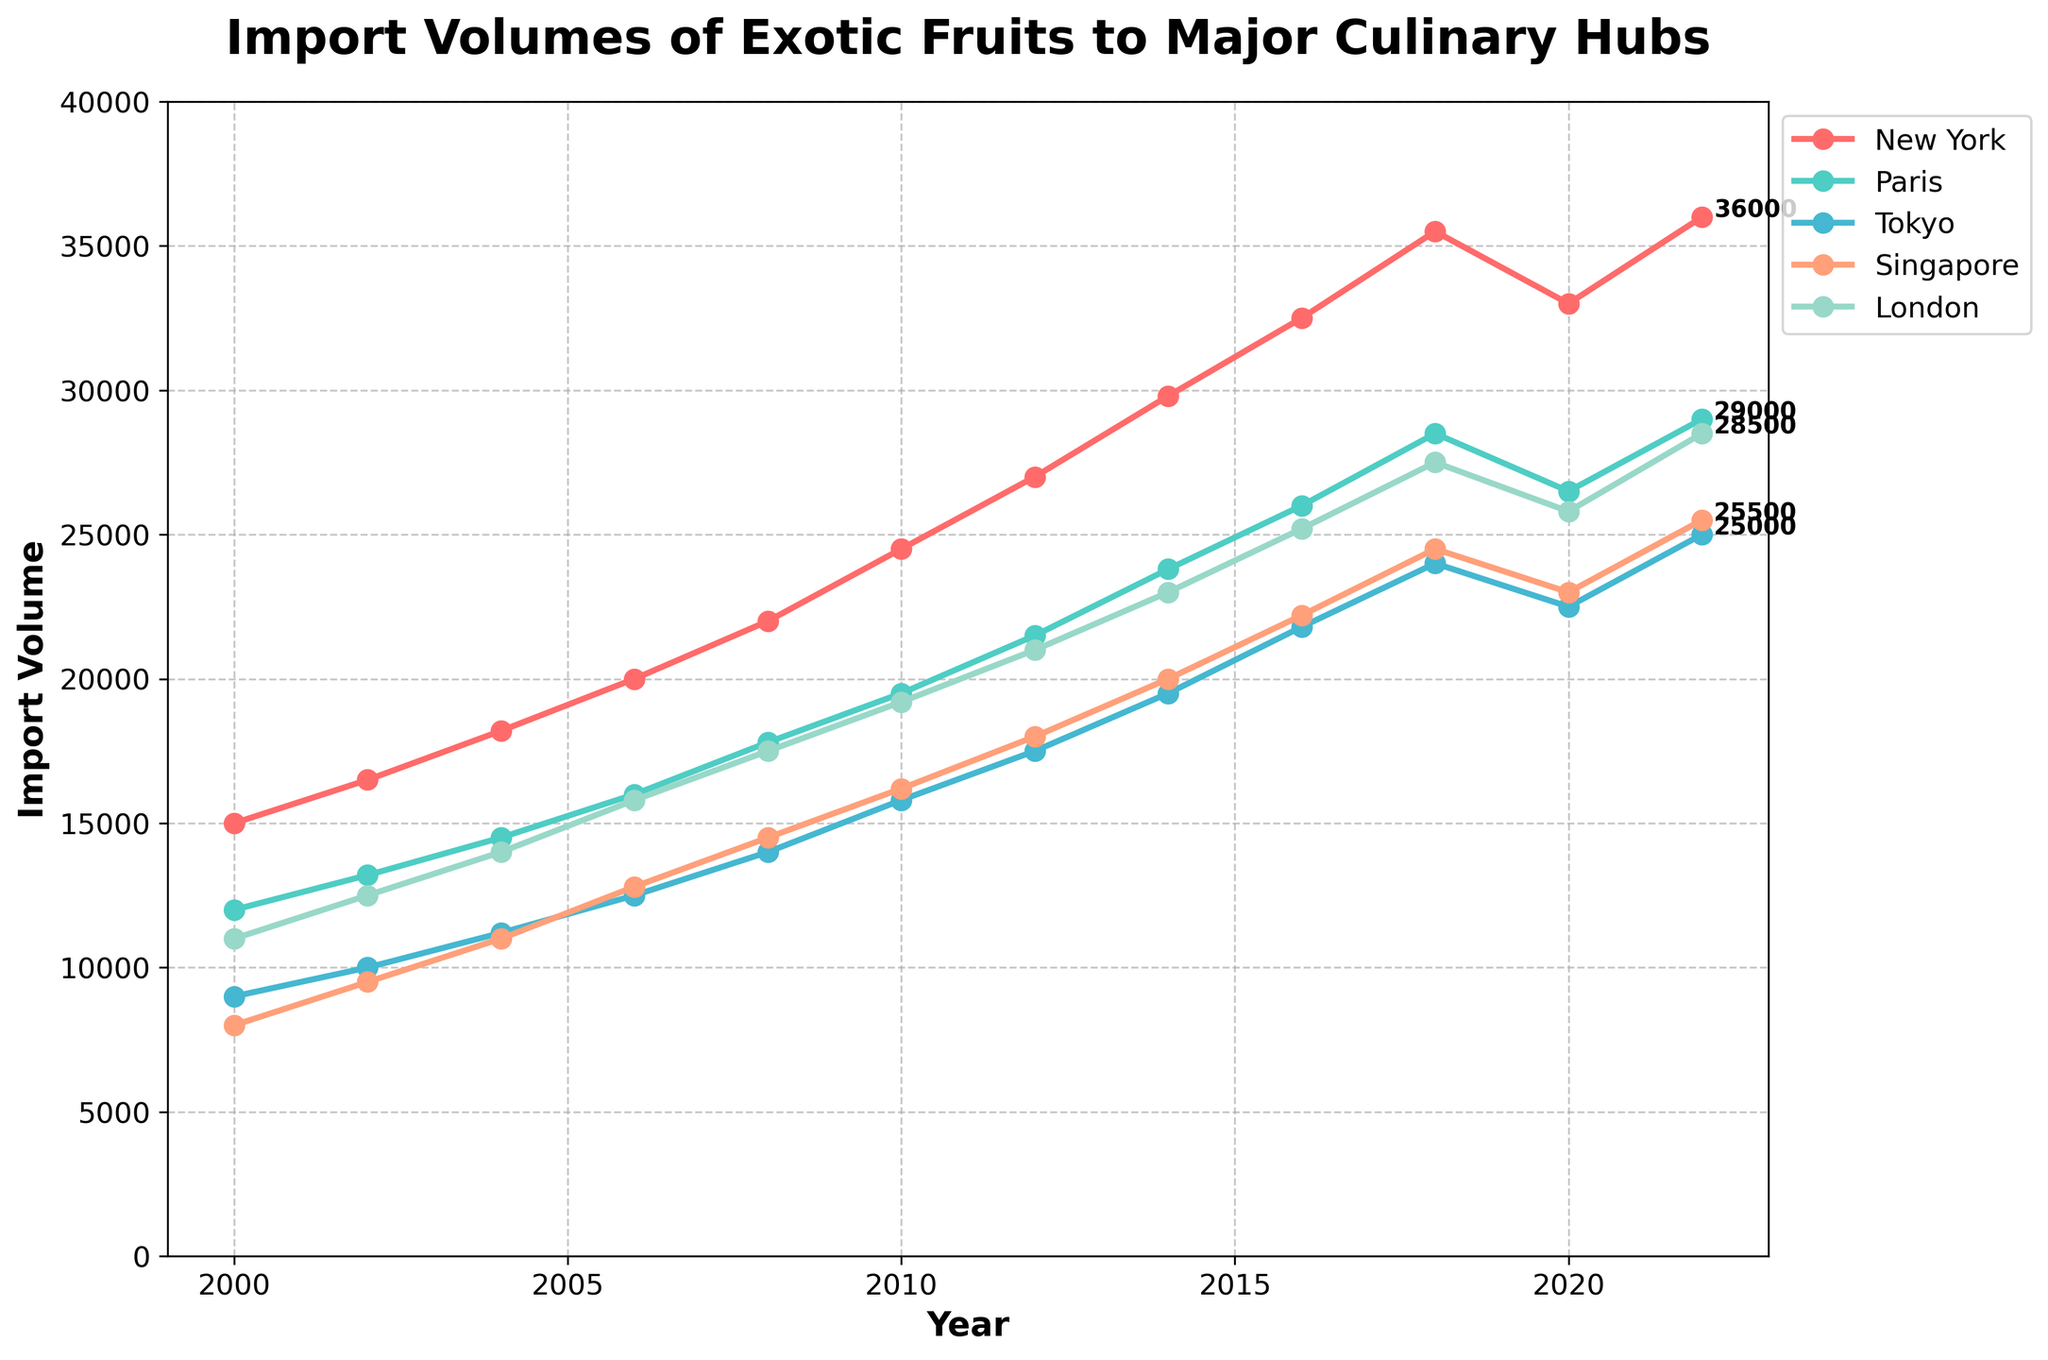Which city had the highest import volume of exotic fruits in 2022? From the graph, observe the import volumes for each city in 2022. The city with the highest value is the one with the tallest point at this year.
Answer: New York How did the import volume in New York change from 2020 to 2022? Look at New York's import volume in 2020 and 2022 and calculate the difference between the two values.
Answer: Increased by 3000 Which city saw the largest increase in import volume from 2000 to 2022? For each city, subtract the 2000 value from the 2022 value and compare the differences.
Answer: New York What is the average import volume of exotic fruits in Tokyo over the entire period? Sum the import volumes for Tokyo from 2000 to 2022 and then divide by the number of years (11).
Answer: 16009.09 Which city had a declining trend in import volumes between 2018 and 2020? Identify the cities whose import volumes are lower in 2020 compared to 2018.
Answer: All cities Compare the import volumes of London and Tokyo in 2016. Which city imported more exotic fruits? Observe the plot for London and Tokyo's import volumes in 2016 and compare the values.
Answer: London What is the trend of import volumes for Singapore? Observe the general direction of the line for Singapore from 2000 to 2022.
Answer: Steady increase In which year did Paris's import volume first exceed 20,000? Identify the first year after 2000 where the import volume for Paris is above 20,000.
Answer: 2012 Calculate the total import volume for London from 2006 to 2016. Sum London's import volumes over the specified years (2006, 2008, 2010, 2012, 2014, 2016).
Answer: 148700 What was the difference in import volume between Paris and Singapore in 2010? Subtract Singapore's import volume from Paris's import volume in 2010.
Answer: 3300 